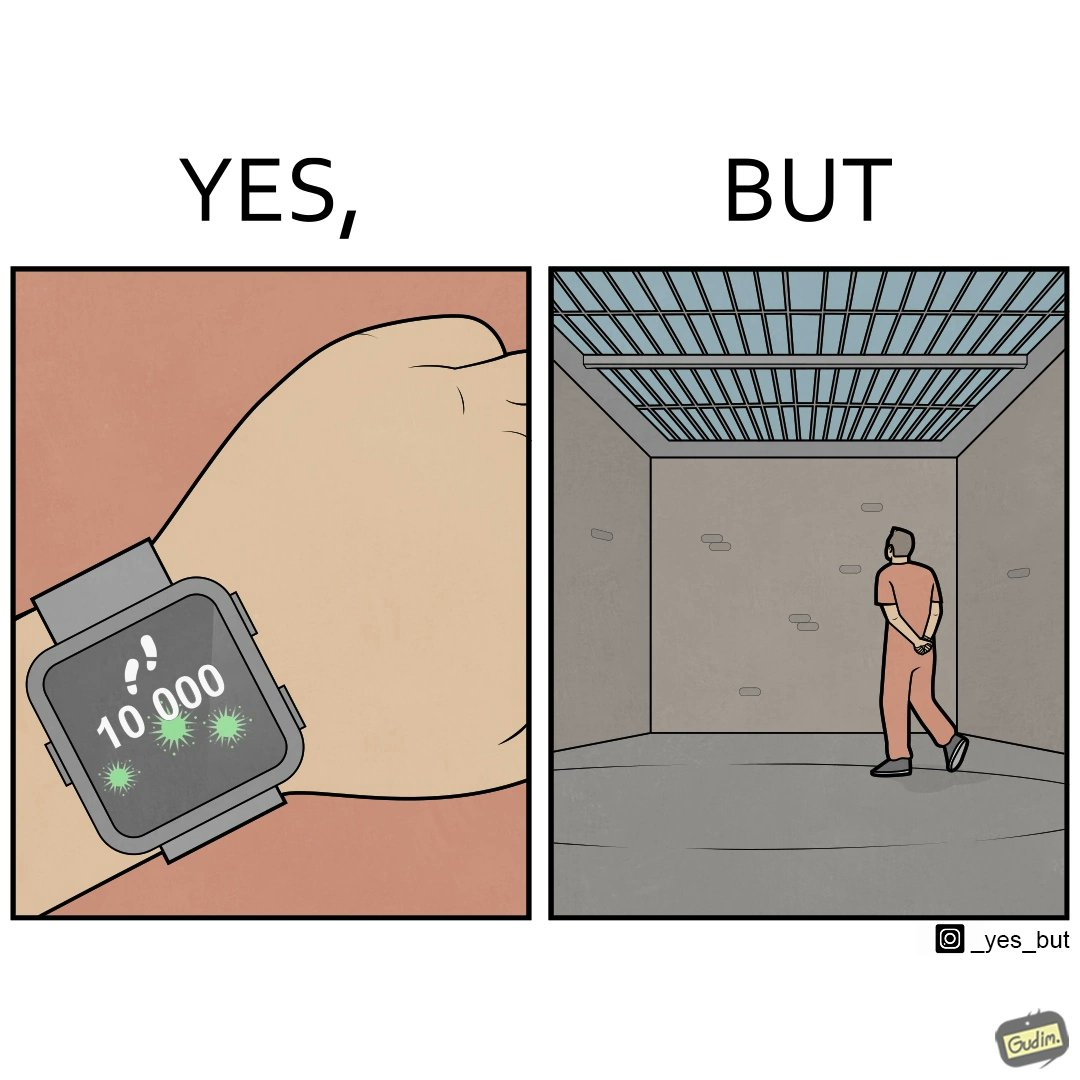Why is this image considered satirical? The image is ironical, as the smartwatch on the person's wrist shows 10,000 steps completed as an accomplishment, while showing later that the person is apparently walking inside a jail as a prisoner. 